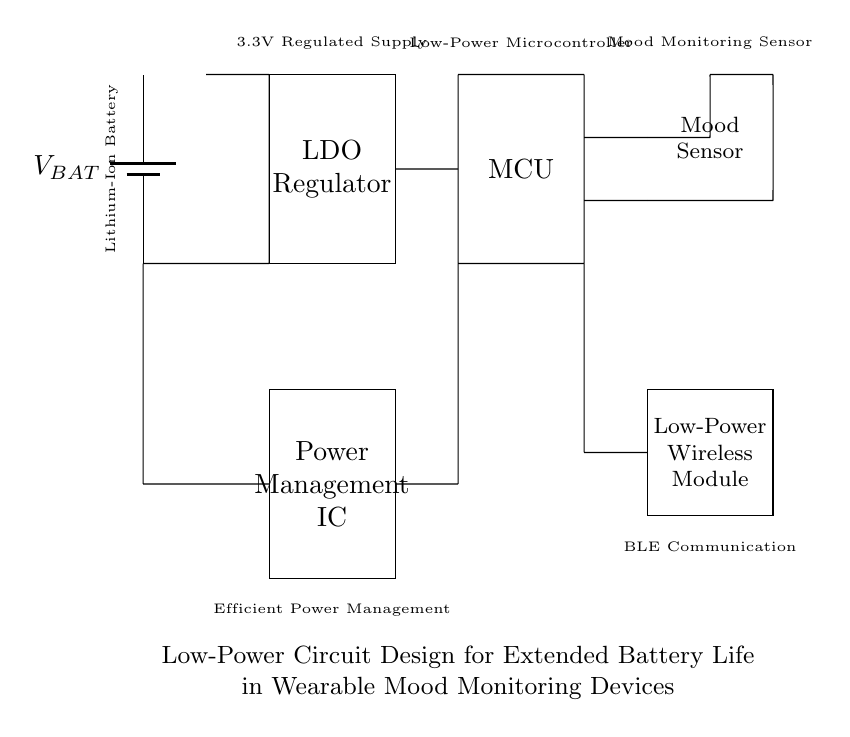What type of battery is used in this circuit? The circuit shows a lithium-ion battery, indicated in the labeled component on the left side of the diagram.
Answer: Lithium-Ion Battery What is the output voltage of the low-dropout regulator? The low-dropout regulator provides a regulated output voltage, typically 3.3V, as indicated by the label in the circuit.
Answer: 3.3V Which component is responsible for mood monitoring? The mood monitoring sensor is identified in the circuit diagram by its label, specifically denoting its function at the far right of the diagram.
Answer: Mood Sensor Explain the role of the power management IC in this circuit. The power management IC is responsible for optimizing power usage throughout the circuit, allowing for efficient distribution of power from the battery to the necessary components, thus extending battery life.
Answer: Power management What components are connected to the microcontroller in this circuit? The microcontroller is connected to the mood sensor and the low-power wireless module, as shown by the lines representing the connections in the circuit diagram.
Answer: Mood Sensor, Low-Power Wireless Module Why is a low-power wireless module used in the design? The low-power wireless module is used to enable communication while minimizing energy consumption, as the device is intended for wearable applications where battery life is critical.
Answer: Minimize energy consumption How does the LDO help in extending battery life? The low-dropout regulator (LDO) ensures that the voltage supplied to other circuit components is stable and efficient, which helps in reducing unnecessary power loss, thus prolonging battery life in wearable devices.
Answer: Reduces power loss 